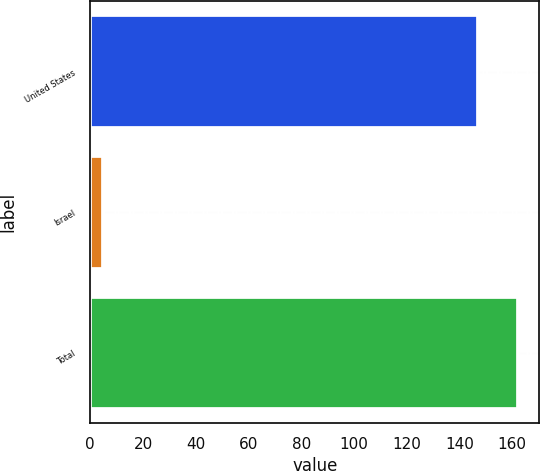<chart> <loc_0><loc_0><loc_500><loc_500><bar_chart><fcel>United States<fcel>Israel<fcel>Total<nl><fcel>147<fcel>5<fcel>162.2<nl></chart> 